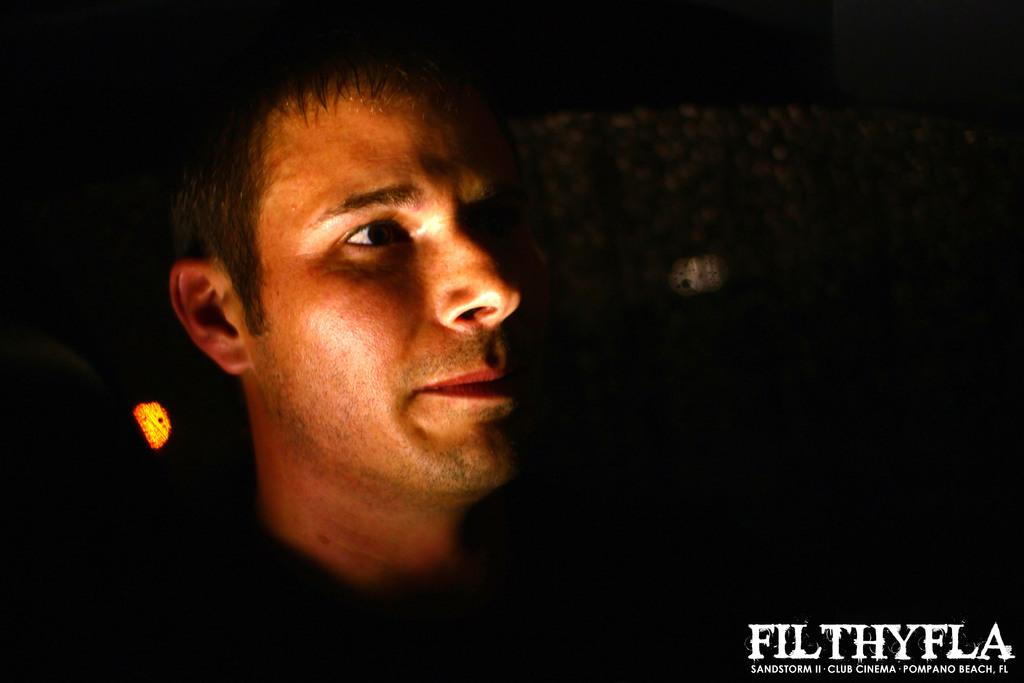Who is present in the image? There is a man visible in the image. What can be observed about the background of the image? The background of the image is dark. What type of trousers is the sun wearing in the image? There is no sun or trousers present in the image; it features a man with a dark background. 